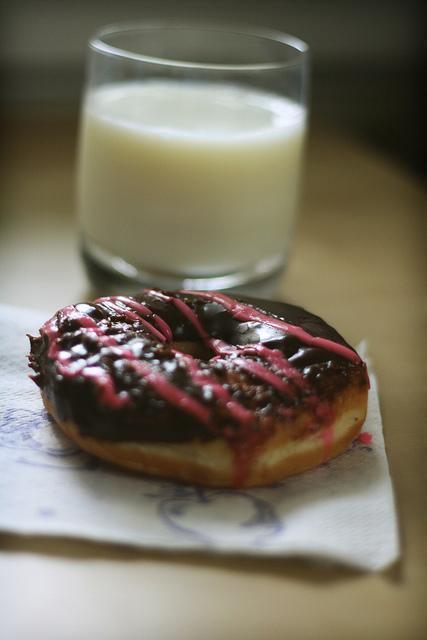Is "The donut is left of the dining table." an appropriate description for the image?
Answer yes or no. No. 